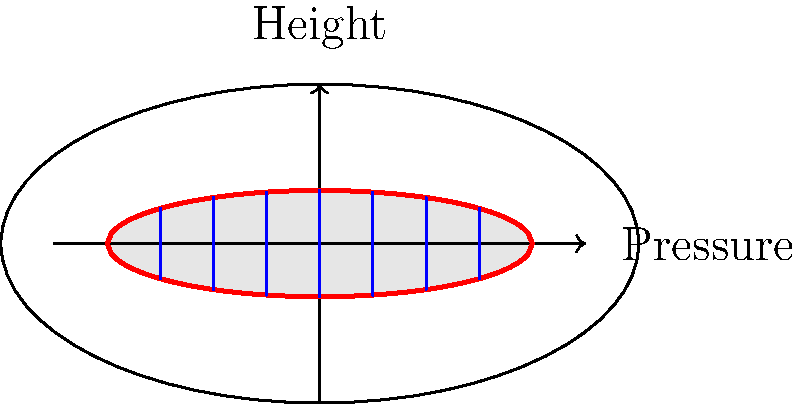In your sustainable bakery, you're optimizing an oven for even baking of plant-based goods. The cross-sectional view of the oven cavity is shown above. How does the pressure distribution inside the oven relate to the height, and why is this important for creating consistent plant-based baked goods? 1. Pressure distribution in an oven:
   - The red curves represent the oven walls.
   - The blue vertical lines represent the pressure at different heights.

2. Relationship between pressure and height:
   - Pressure decreases with increasing height due to gravity.
   - This relationship is described by the hydrostatic equation: $$\frac{dP}{dh} = -\rho g$$
   where $P$ is pressure, $h$ is height, $\rho$ is density of air, and $g$ is gravitational acceleration.

3. Pressure gradient:
   - The pressure gradient is steeper near the bottom of the oven.
   - It becomes less steep towards the top.

4. Importance for baking:
   - Even heat distribution is crucial for consistent baking.
   - Pressure affects heat transfer and air circulation in the oven.
   - Lower pressure at the top can cause hot air to rise, creating convection currents.

5. Impact on plant-based baking:
   - Plant-based ingredients may be more sensitive to temperature variations.
   - Understanding pressure distribution helps in:
     a. Adjusting rack positions for different types of baked goods.
     b. Ensuring even browning and texture throughout the product.
     c. Optimizing baking times and temperatures for various plant-based recipes.

6. Practical applications:
   - Place items requiring more heat (e.g., bread) lower in the oven.
   - Position delicate items (e.g., pastries) in the middle or upper racks.
   - Use convection settings to promote air circulation and even baking.
Answer: Pressure decreases with height, creating convection currents that affect heat distribution and baking consistency. 